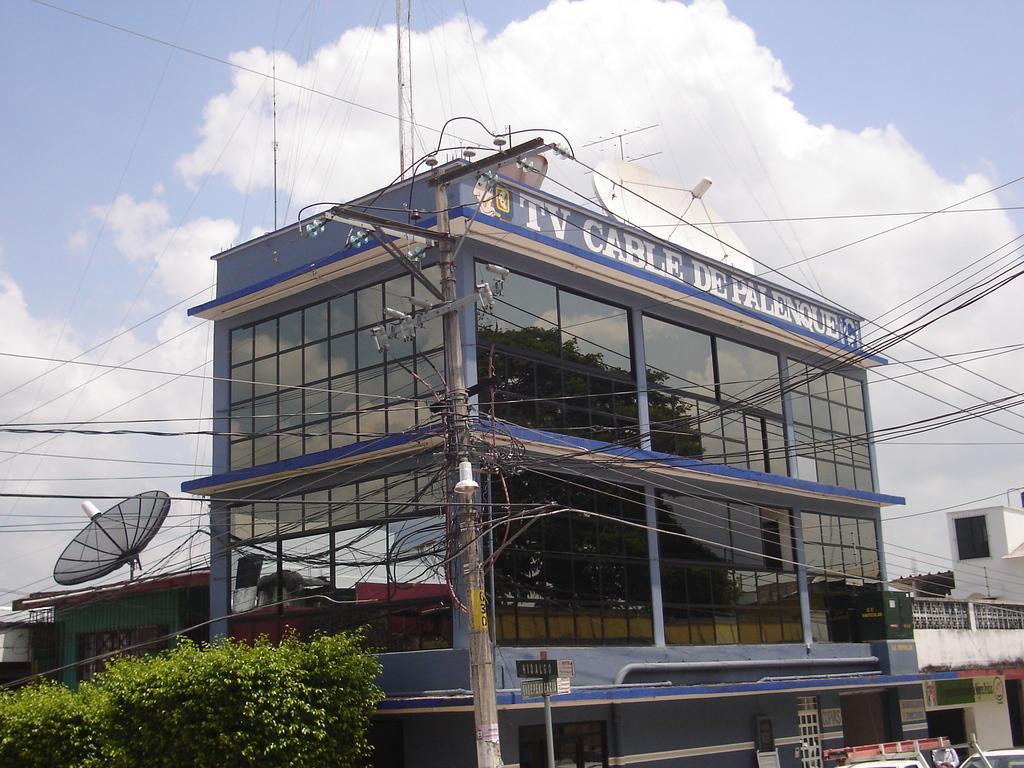Could you give a brief overview of what you see in this image? In this image, we can see a building, we can see some green trees, at the top we can see the sky and some clouds. 